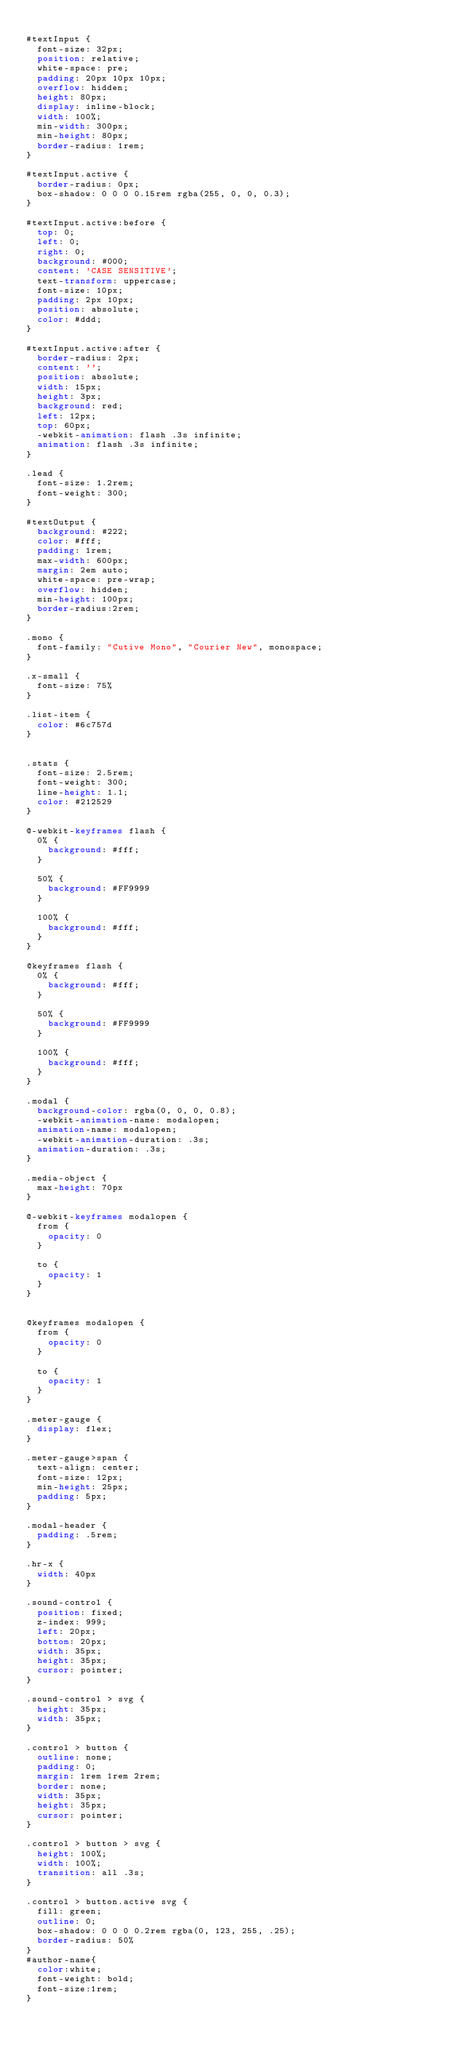<code> <loc_0><loc_0><loc_500><loc_500><_CSS_>
#textInput {
  font-size: 32px;
  position: relative;
  white-space: pre;
  padding: 20px 10px 10px;
  overflow: hidden;
  height: 80px;
  display: inline-block;
  width: 100%;
  min-width: 300px;
  min-height: 80px;
  border-radius: 1rem;
}

#textInput.active {
  border-radius: 0px;
  box-shadow: 0 0 0 0.15rem rgba(255, 0, 0, 0.3);
}

#textInput.active:before {
  top: 0;
  left: 0;
  right: 0;
  background: #000;
  content: 'CASE SENSITIVE';
  text-transform: uppercase;
  font-size: 10px;
  padding: 2px 10px;
  position: absolute;
  color: #ddd;
}

#textInput.active:after {
  border-radius: 2px;
  content: '';
  position: absolute;
  width: 15px;
  height: 3px;
  background: red;
  left: 12px;
  top: 60px;
  -webkit-animation: flash .3s infinite;
  animation: flash .3s infinite;
}

.lead {
  font-size: 1.2rem;
  font-weight: 300;
}

#textOutput {
  background: #222;
  color: #fff;
  padding: 1rem;
  max-width: 600px;
  margin: 2em auto;
  white-space: pre-wrap;
  overflow: hidden;
  min-height: 100px;
  border-radius:2rem;
}

.mono {
  font-family: "Cutive Mono", "Courier New", monospace;
}

.x-small {
  font-size: 75%
}

.list-item {
  color: #6c757d
}


.stats {
  font-size: 2.5rem;
  font-weight: 300;
  line-height: 1.1;
  color: #212529
}

@-webkit-keyframes flash {
  0% {
    background: #fff;
  }

  50% {
    background: #FF9999
  }

  100% {
    background: #fff;
  }
}

@keyframes flash {
  0% {
    background: #fff;
  }

  50% {
    background: #FF9999
  }

  100% {
    background: #fff;
  }
}

.modal {
  background-color: rgba(0, 0, 0, 0.8);
  -webkit-animation-name: modalopen;
  animation-name: modalopen;
  -webkit-animation-duration: .3s;
  animation-duration: .3s;
}

.media-object {
  max-height: 70px
}

@-webkit-keyframes modalopen {
  from {
    opacity: 0
  }

  to {
    opacity: 1
  }
}


@keyframes modalopen {
  from {
    opacity: 0
  }

  to {
    opacity: 1
  }
}

.meter-gauge {
  display: flex;
}

.meter-gauge>span {
  text-align: center;
  font-size: 12px;
  min-height: 25px;
  padding: 5px;
}

.modal-header {
  padding: .5rem;
}

.hr-x {
  width: 40px
}

.sound-control {
  position: fixed;
  z-index: 999;
  left: 20px;
  bottom: 20px;
  width: 35px;
  height: 35px;
  cursor: pointer;
}

.sound-control > svg {
  height: 35px;
  width: 35px;
}

.control > button {
  outline: none;
  padding: 0;
  margin: 1rem 1rem 2rem;
  border: none;
  width: 35px;
  height: 35px;
  cursor: pointer;
}

.control > button > svg {
  height: 100%;
  width: 100%;
  transition: all .3s;
}

.control > button.active svg {
  fill: green;
  outline: 0;
  box-shadow: 0 0 0 0.2rem rgba(0, 123, 255, .25);
  border-radius: 50%
}
#author-name{
  color:white;
  font-weight: bold;
  font-size:1rem;
}
</code> 